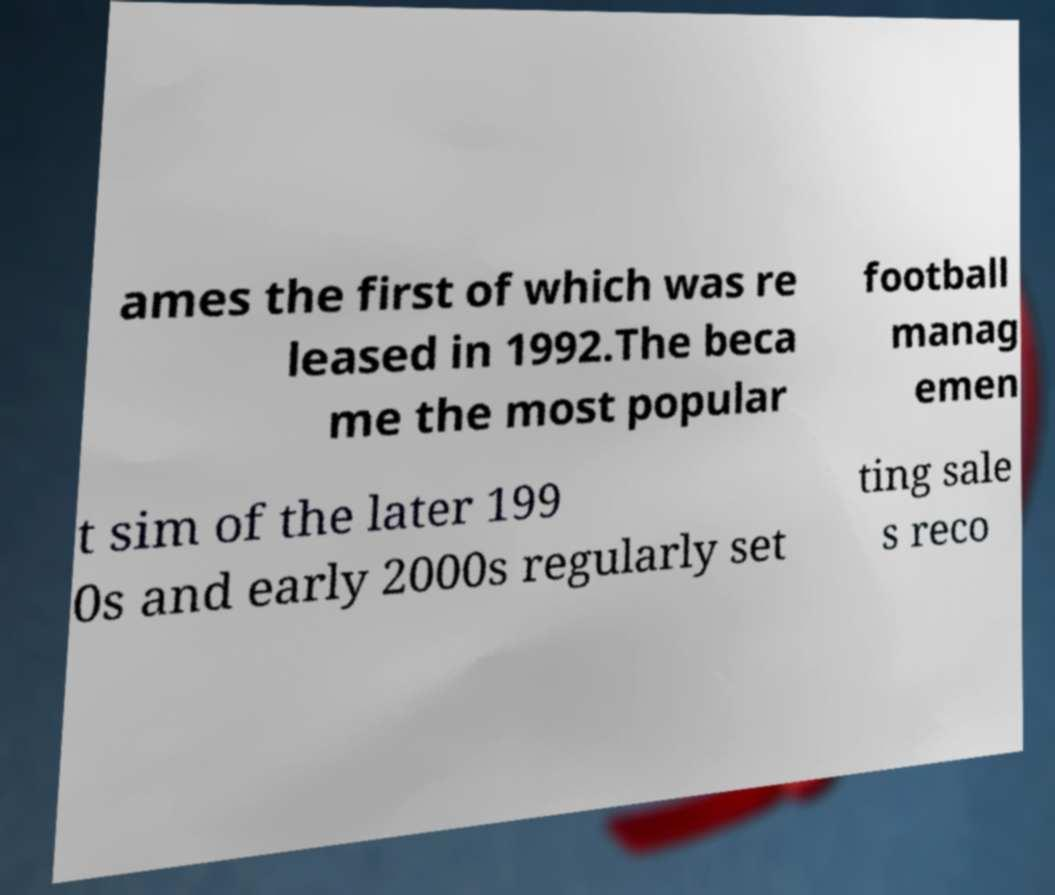What messages or text are displayed in this image? I need them in a readable, typed format. ames the first of which was re leased in 1992.The beca me the most popular football manag emen t sim of the later 199 0s and early 2000s regularly set ting sale s reco 